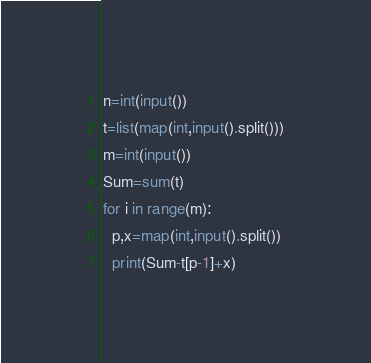<code> <loc_0><loc_0><loc_500><loc_500><_Python_>n=int(input())
t=list(map(int,input().split()))
m=int(input())
Sum=sum(t)
for i in range(m):
  p,x=map(int,input().split())
  print(Sum-t[p-1]+x)</code> 